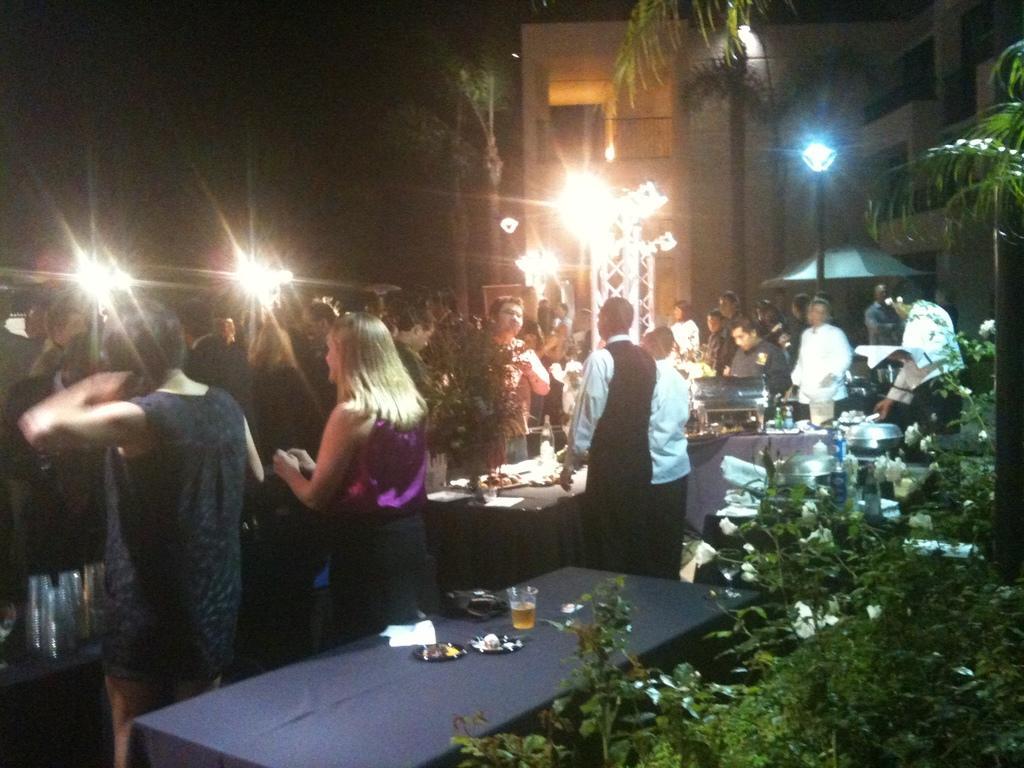Describe this image in one or two sentences. In this image there are Group of persons standing. In the center there is a table which is covered with a blue colour cloth. On the table there is a glass and there is a black colour object. On the right side there are plants and there is a light pole and there are trees. On the left side there are lights. In the background there is a building and there are trees on the left side of the building. 